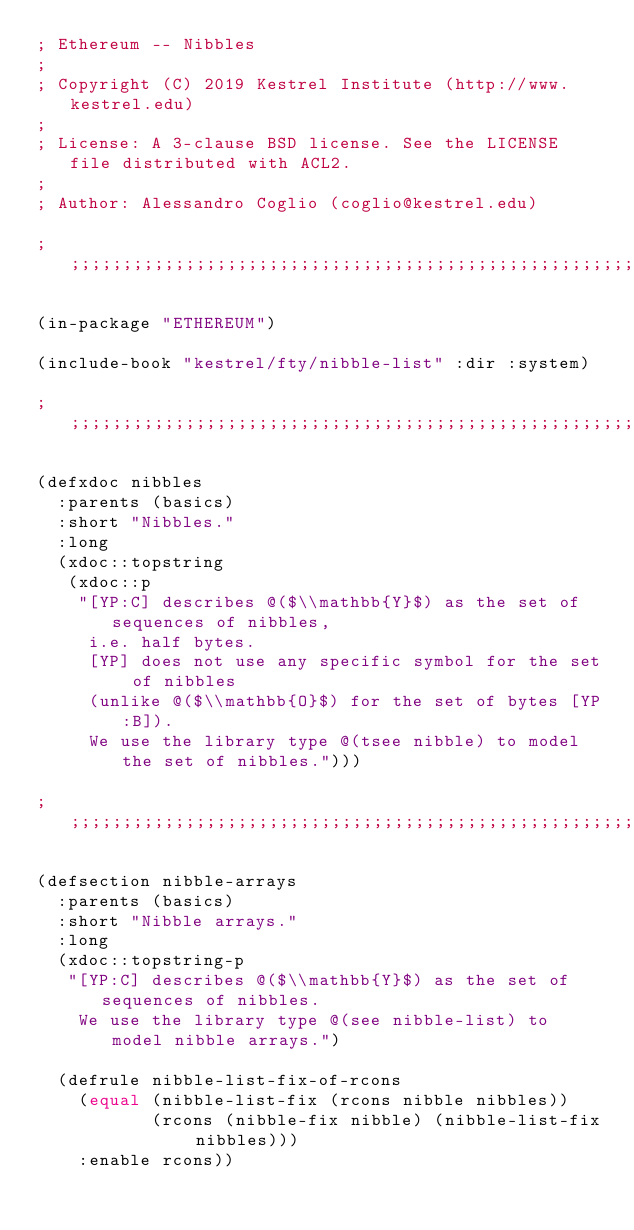Convert code to text. <code><loc_0><loc_0><loc_500><loc_500><_Lisp_>; Ethereum -- Nibbles
;
; Copyright (C) 2019 Kestrel Institute (http://www.kestrel.edu)
;
; License: A 3-clause BSD license. See the LICENSE file distributed with ACL2.
;
; Author: Alessandro Coglio (coglio@kestrel.edu)

;;;;;;;;;;;;;;;;;;;;;;;;;;;;;;;;;;;;;;;;;;;;;;;;;;;;;;;;;;;;;;;;;;;;;;;;;;;;;;;;

(in-package "ETHEREUM")

(include-book "kestrel/fty/nibble-list" :dir :system)

;;;;;;;;;;;;;;;;;;;;;;;;;;;;;;;;;;;;;;;;;;;;;;;;;;;;;;;;;;;;;;;;;;;;;;;;;;;;;;;;

(defxdoc nibbles
  :parents (basics)
  :short "Nibbles."
  :long
  (xdoc::topstring
   (xdoc::p
    "[YP:C] describes @($\\mathbb{Y}$) as the set of sequences of nibbles,
     i.e. half bytes.
     [YP] does not use any specific symbol for the set of nibbles
     (unlike @($\\mathbb{O}$) for the set of bytes [YP:B]).
     We use the library type @(tsee nibble) to model the set of nibbles.")))

;;;;;;;;;;;;;;;;;;;;;;;;;;;;;;;;;;;;;;;;;;;;;;;;;;;;;;;;;;;;;;;;;;;;;;;;;;;;;;;;

(defsection nibble-arrays
  :parents (basics)
  :short "Nibble arrays."
  :long
  (xdoc::topstring-p
   "[YP:C] describes @($\\mathbb{Y}$) as the set of sequences of nibbles.
    We use the library type @(see nibble-list) to model nibble arrays.")

  (defrule nibble-list-fix-of-rcons
    (equal (nibble-list-fix (rcons nibble nibbles))
           (rcons (nibble-fix nibble) (nibble-list-fix nibbles)))
    :enable rcons))
</code> 